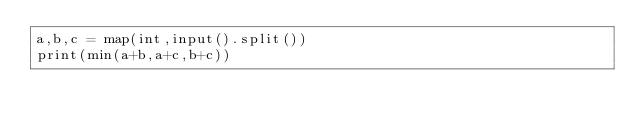Convert code to text. <code><loc_0><loc_0><loc_500><loc_500><_Python_>a,b,c = map(int,input().split())
print(min(a+b,a+c,b+c))</code> 